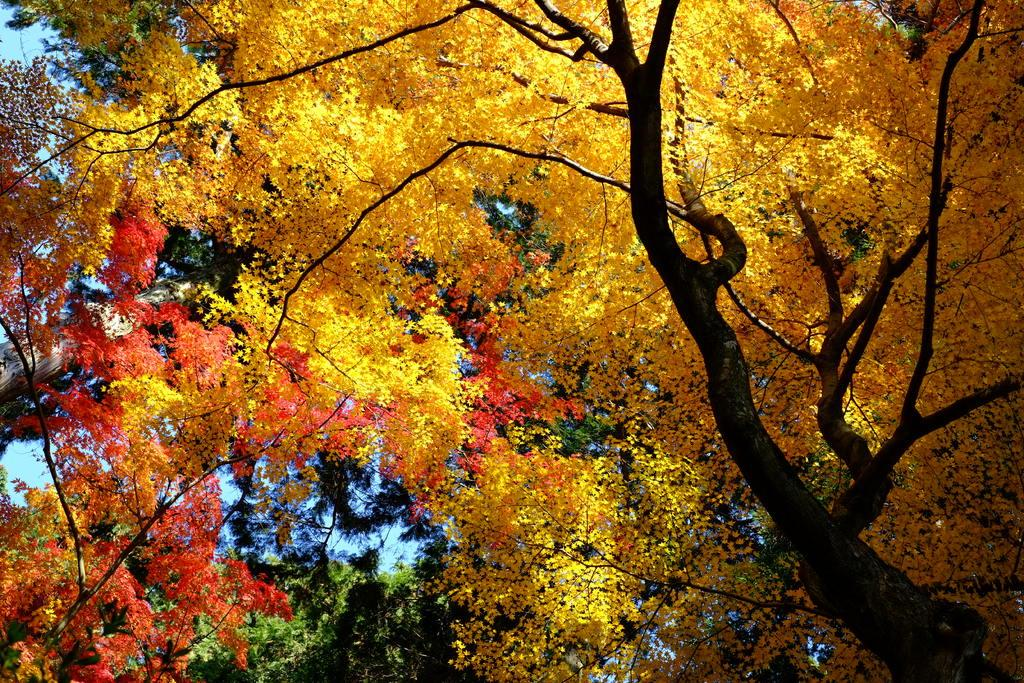What is the main subject of the image? There is a tree in the image. What is unique about the tree in the image? The tree has many yellow leaves. What can be seen in the background of the image? There are trees in the background of the image. What type of engine is visible in the image? There is no engine present in the image; it features a tree with yellow leaves. Can you tell me how many rifles are leaning against the tree in the image? There are no rifles present in the image; it only features a tree with yellow leaves. 